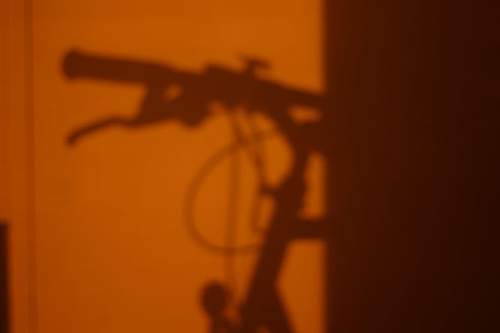<image>Where are the people at? It is ambiguous where the people are. There may not be any people present in the image. Where are the people at? I don't know where the people are at. They can be anywhere such as in the house, garage, or on the beach. 